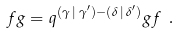Convert formula to latex. <formula><loc_0><loc_0><loc_500><loc_500>f g = q ^ { ( \gamma \, | \, \gamma ^ { \prime } ) - ( \delta \, | \, \delta ^ { \prime } ) } g f \ .</formula> 